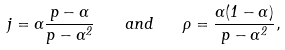Convert formula to latex. <formula><loc_0><loc_0><loc_500><loc_500>j = \alpha \frac { p - \alpha } { p - \alpha ^ { 2 } } \quad a n d \quad \rho = \frac { \alpha ( 1 - \alpha ) } { p - \alpha ^ { 2 } } ,</formula> 